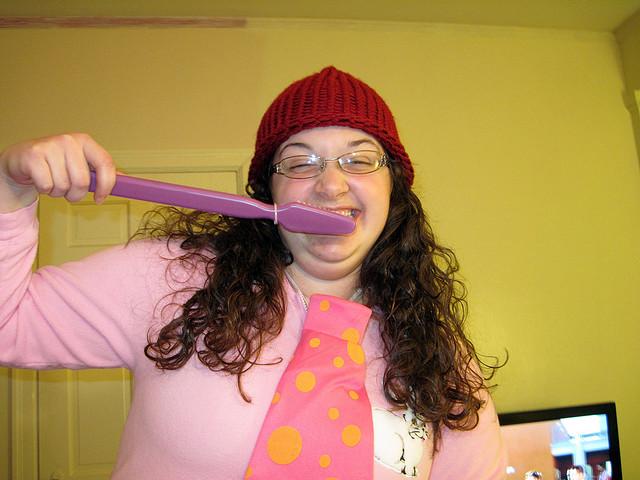Is the lady smiling?
Write a very short answer. Yes. What type of head covering is the lady wearing?
Keep it brief. Hat. What color is the toothbrush?
Write a very short answer. Purple. 